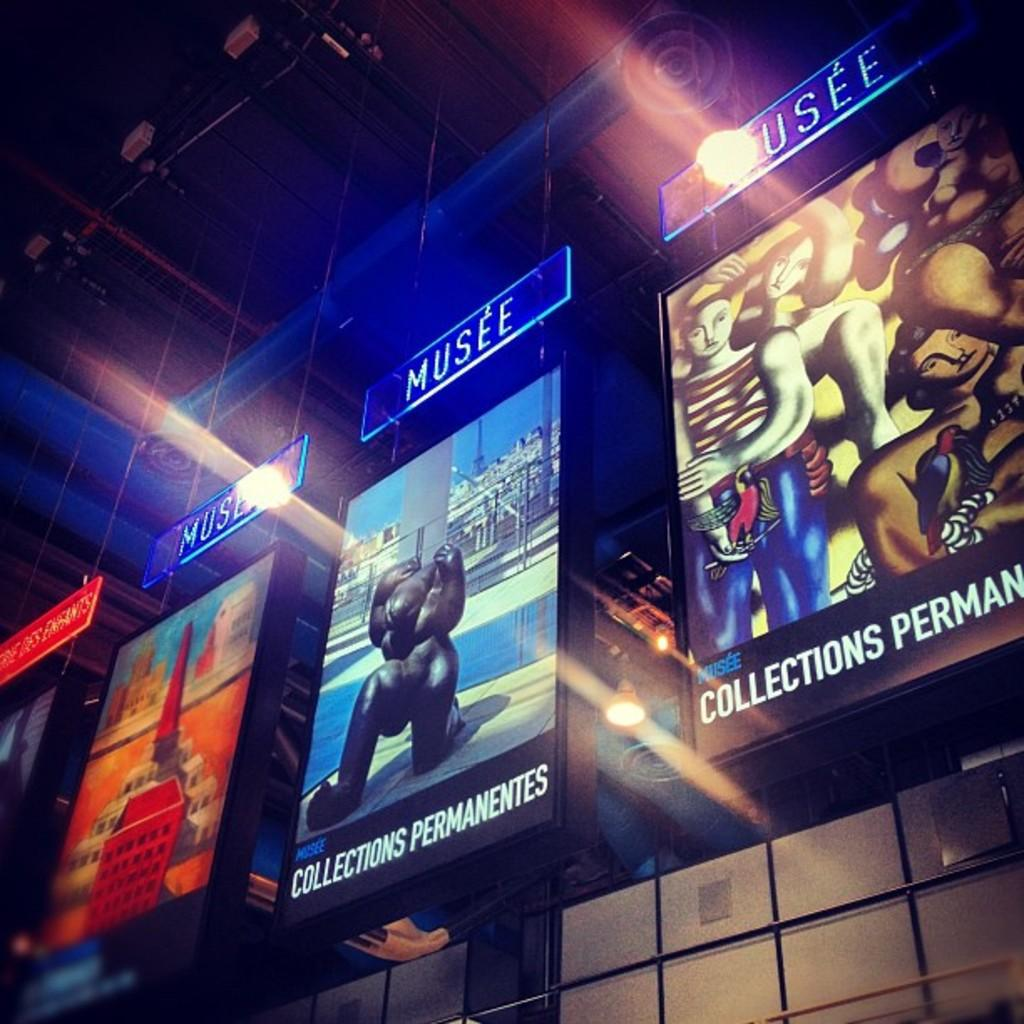<image>
Render a clear and concise summary of the photo. Colorful advertisements of artworks are encased in displays that says "MUSEE" on top. 